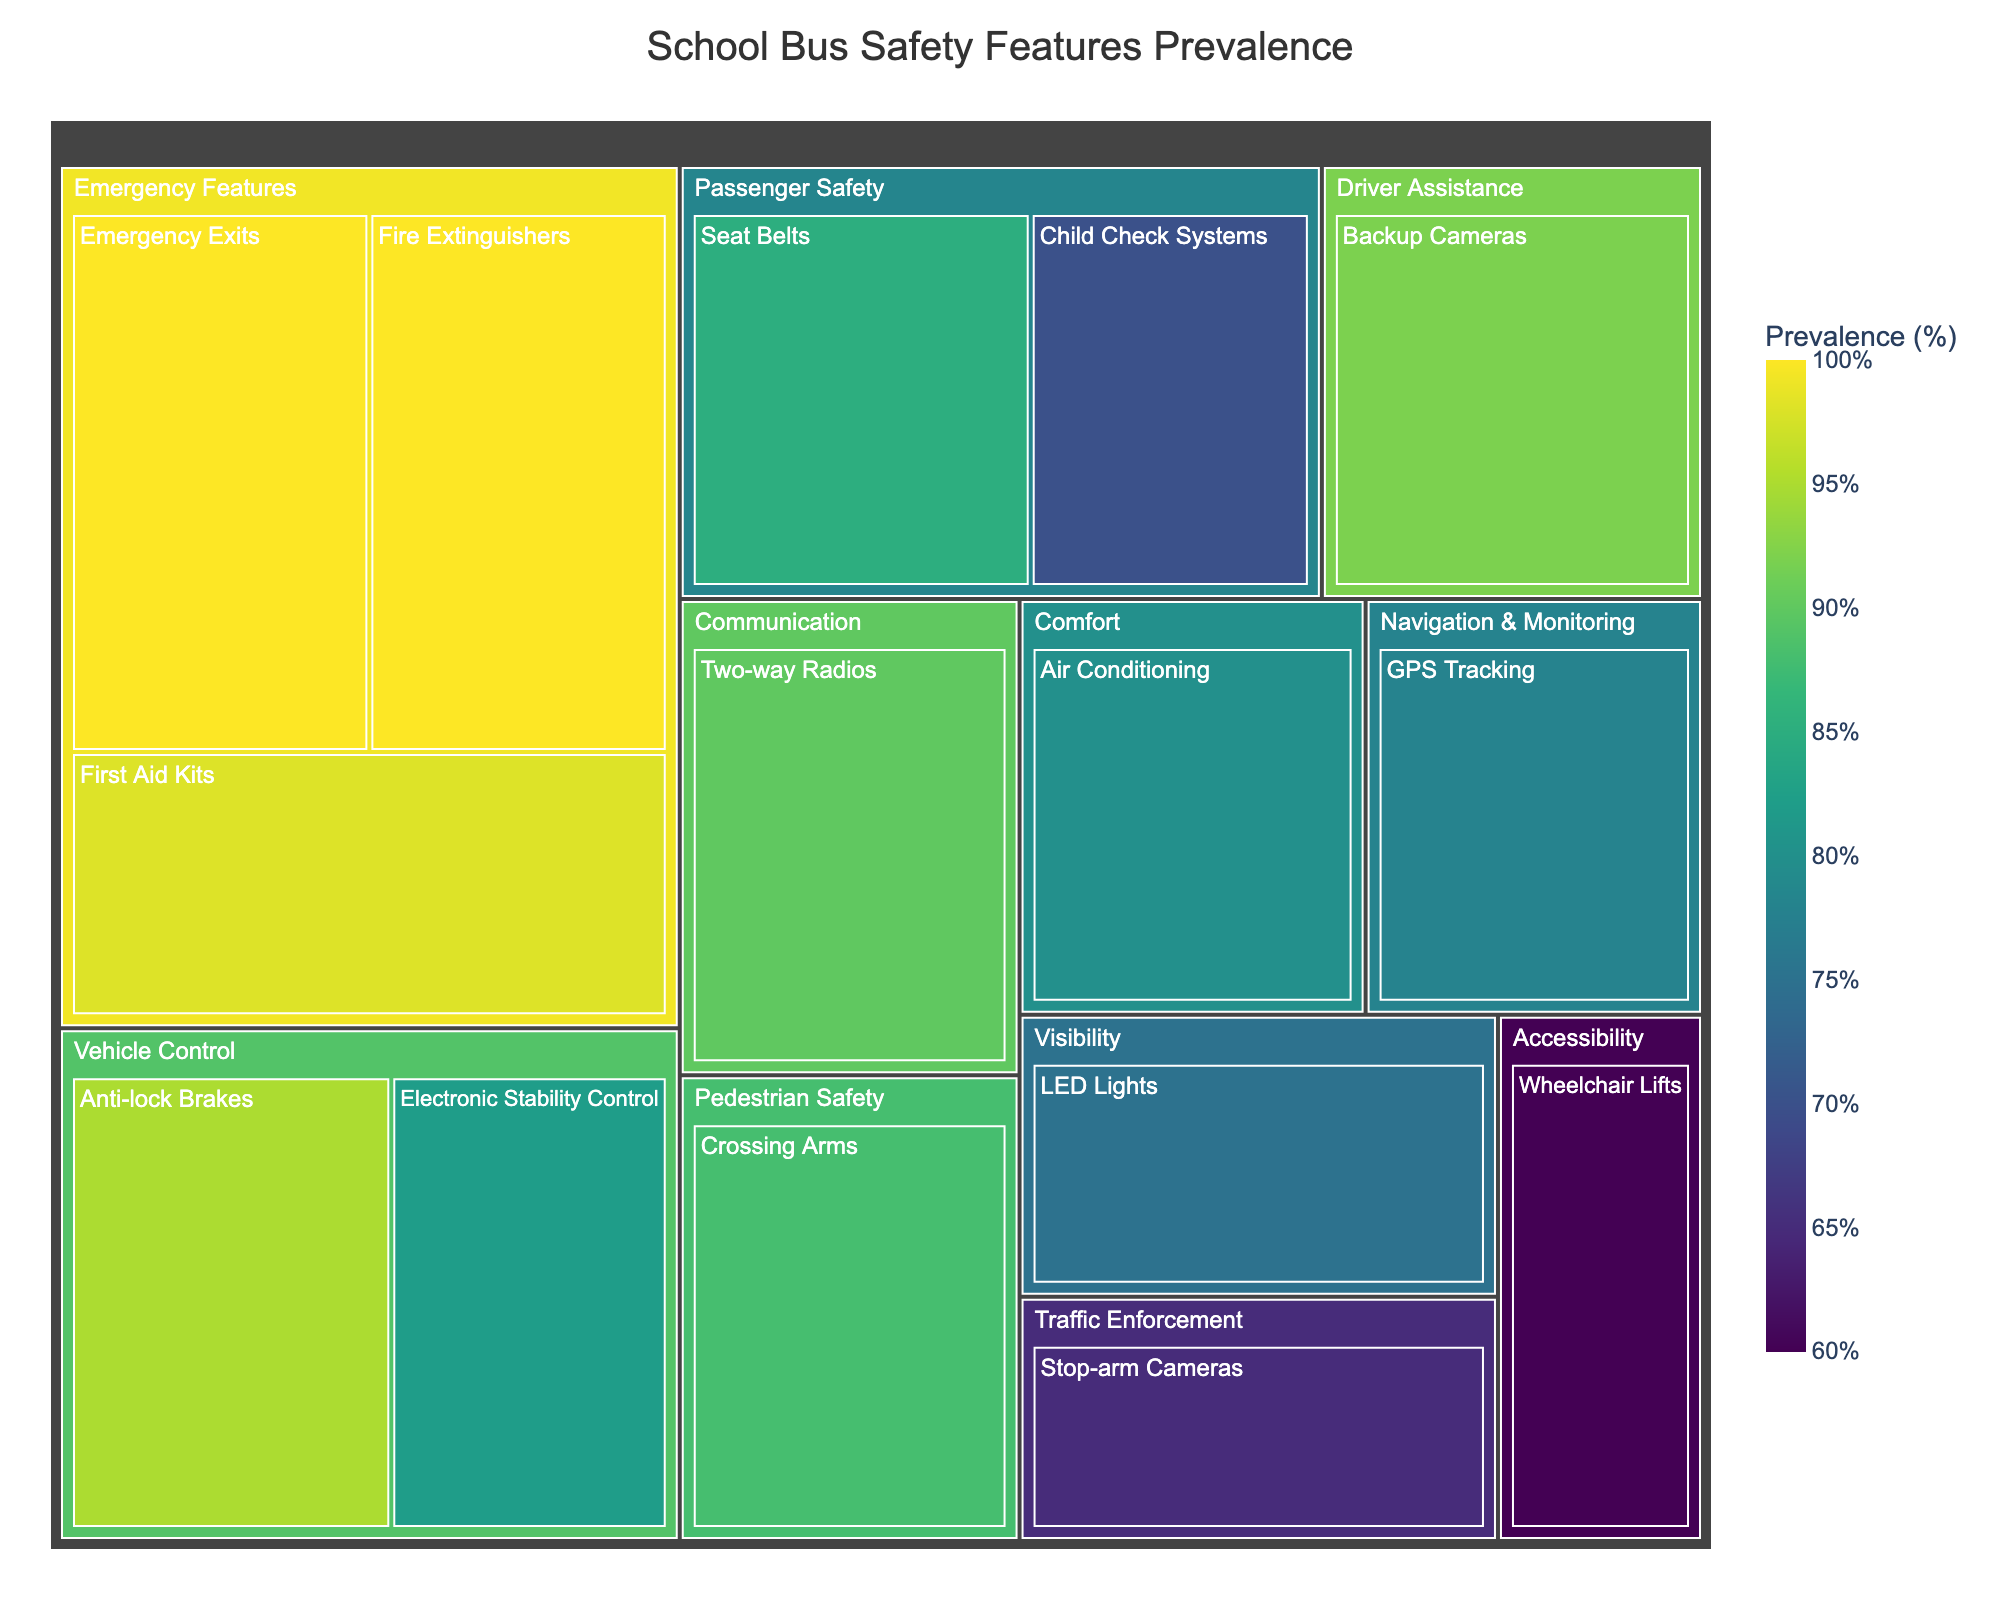How many categories are shown in the treemap? The treemap showcases distinct sections for different safety features of school buses. By counting each unique category labeled in the plot, we find there are 8 categories.
Answer: 8 Which feature has the highest prevalence in the "Emergency Features" category? Looking at the "Emergency Features" group within the treemap, we observe the percentage values for each feature. Both "Emergency Exits" and "Fire Extinguishers" are at 100%, the highest in this category.
Answer: Emergency Exits and Fire Extinguishers Which category has the overall highest average prevalence of features? Calculating the average prevalence for each category involves summing the percentages of all features in that category and dividing by the number of features. By examining each category, "Emergency Features" has the highest average, calculated as (100 + 100 + 98) / 3 = 99.33%.
Answer: Emergency Features Which feature in the "Driver Assistance" category has the lowest prevalence? In the "Driver Assistance" section of the treemap, identify each feature's prevalence. "Backup Cameras" is the only feature and has a prevalence of 92%.
Answer: Backup Cameras Compare the prevalence of "Seat Belts" and "Child Check Systems" in the "Passenger Safety" category. Which is more common? In the "Passenger Safety" category, "Seat Belts" has a prevalence of 85%, while "Child Check Systems" has 70%. Comparing these values, "Seat Belts" is more common.
Answer: Seat Belts What's the least prevalent feature in a school bus according to the treemap? By scanning all the prevalence values in the treemap, we see that the "Wheelchair Lifts" in the "Accessibility" category has the lowest prevalence at 60%.
Answer: Wheelchair Lifts If you combine the prevalence of "GPS Tracking" and "Two-way Radios," what is their total? Adding the prevalence values for "GPS Tracking" (78%) and "Two-way Radios" (90%) gives a combined total prevalence of 78 + 90 = 168%.
Answer: 168% What’s the median prevalence value of the features in the figure? List all prevalence values: 60, 65, 70, 75, 78, 80, 82, 85, 88, 90, 92, 95, 98, 100, 100. The median value falls in the middle of this ordered list. For the list of 15 elements, the median is the 8th value: 85%.
Answer: 85% Which category contains the "LED Lights" feature, and what is its prevalence? By referencing the "LED Lights" within the treemap, we note it falls under the "Visibility" category and has a prevalence of 75%.
Answer: Visibility, 75% 